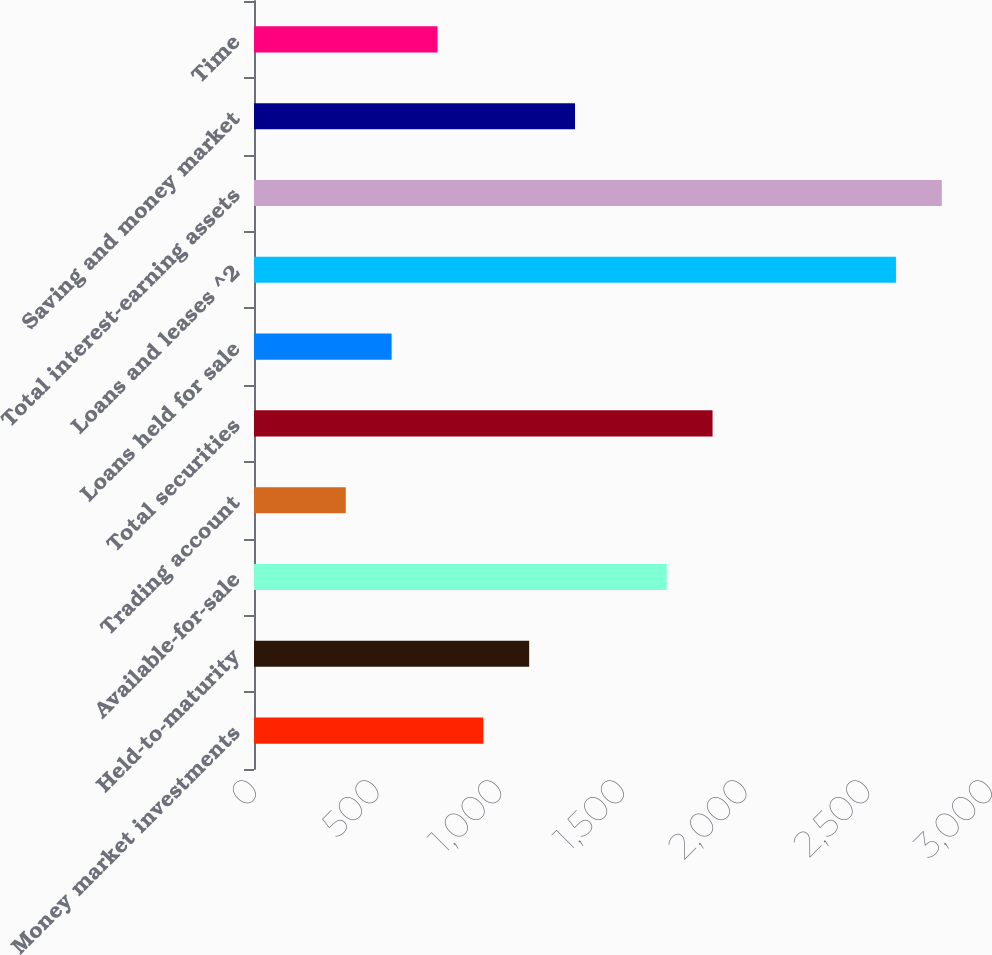Convert chart. <chart><loc_0><loc_0><loc_500><loc_500><bar_chart><fcel>Money market investments<fcel>Held-to-maturity<fcel>Available-for-sale<fcel>Trading account<fcel>Total securities<fcel>Loans held for sale<fcel>Loans and leases ^2<fcel>Total interest-earning assets<fcel>Saving and money market<fcel>Time<nl><fcel>934.7<fcel>1121.58<fcel>1682.22<fcel>374.06<fcel>1869.1<fcel>560.94<fcel>2616.62<fcel>2803.5<fcel>1308.46<fcel>747.82<nl></chart> 